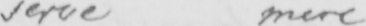What is written in this line of handwriting? serve mere 